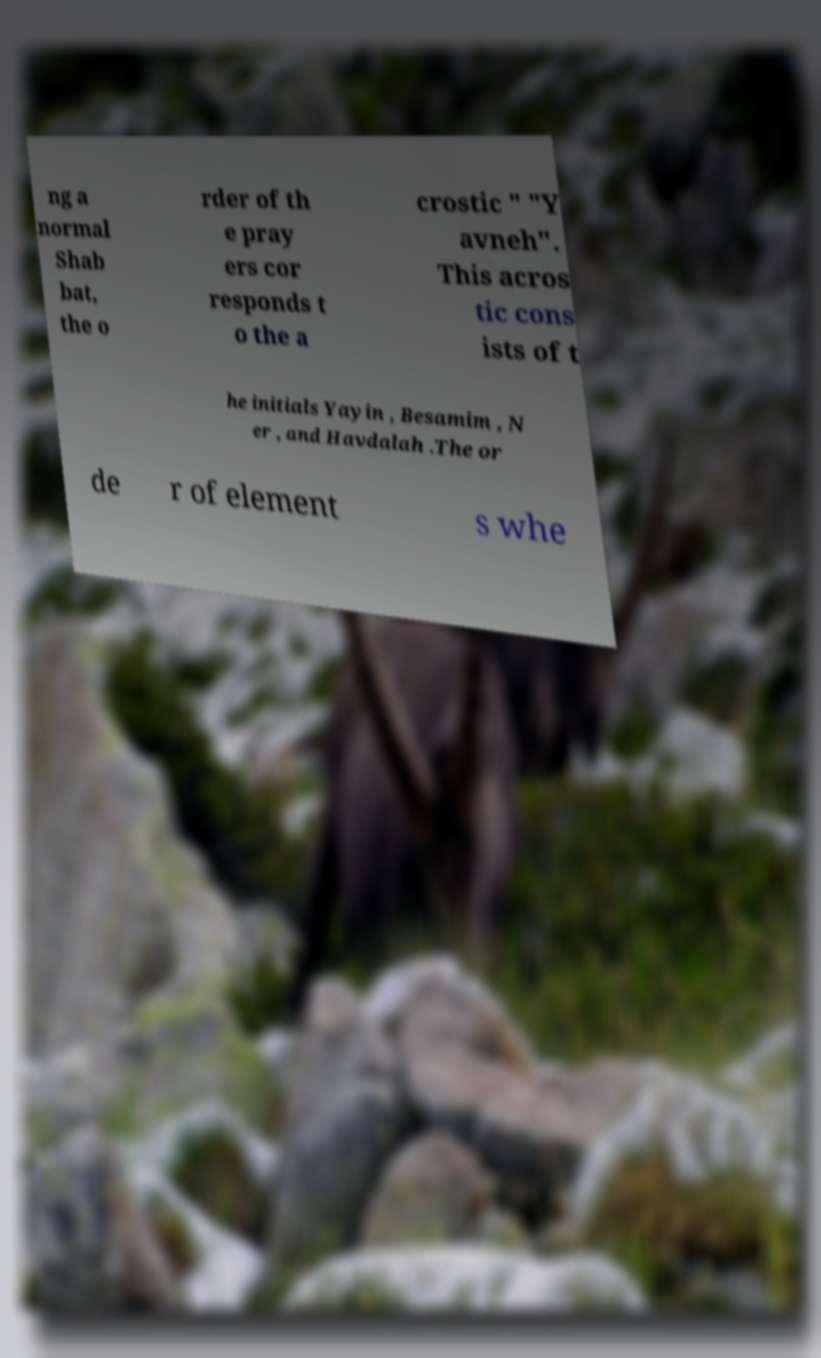There's text embedded in this image that I need extracted. Can you transcribe it verbatim? ng a normal Shab bat, the o rder of th e pray ers cor responds t o the a crostic " "Y avneh". This acros tic cons ists of t he initials Yayin , Besamim , N er , and Havdalah .The or de r of element s whe 